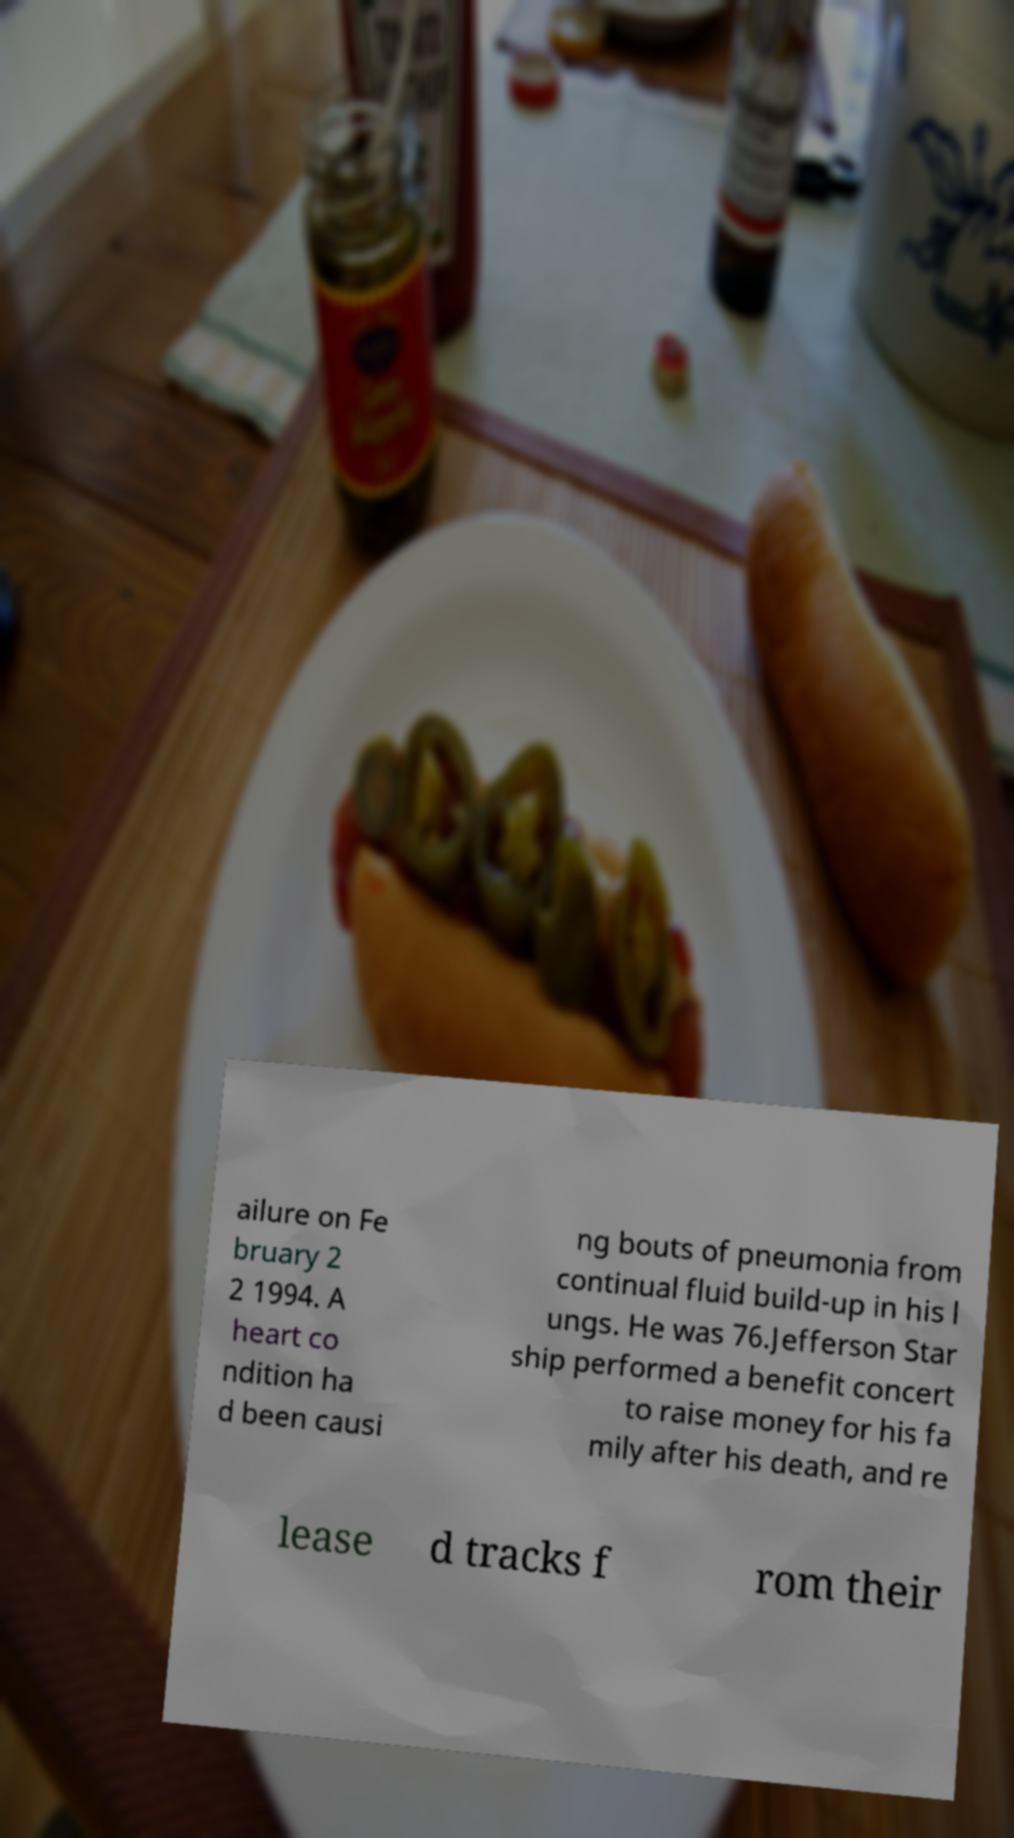Can you read and provide the text displayed in the image?This photo seems to have some interesting text. Can you extract and type it out for me? ailure on Fe bruary 2 2 1994. A heart co ndition ha d been causi ng bouts of pneumonia from continual fluid build-up in his l ungs. He was 76.Jefferson Star ship performed a benefit concert to raise money for his fa mily after his death, and re lease d tracks f rom their 